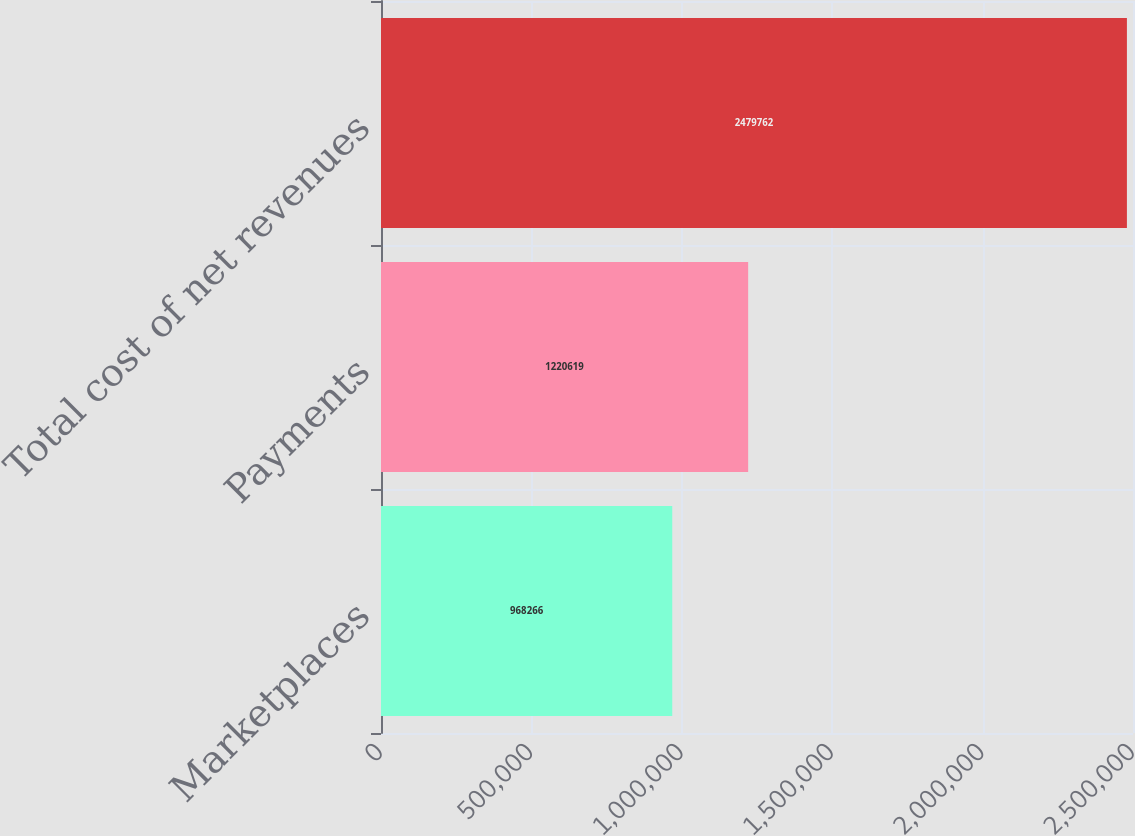Convert chart to OTSL. <chart><loc_0><loc_0><loc_500><loc_500><bar_chart><fcel>Marketplaces<fcel>Payments<fcel>Total cost of net revenues<nl><fcel>968266<fcel>1.22062e+06<fcel>2.47976e+06<nl></chart> 